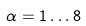<formula> <loc_0><loc_0><loc_500><loc_500>\alpha = 1 \dots 8</formula> 